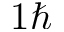<formula> <loc_0><loc_0><loc_500><loc_500>1 \hbar</formula> 